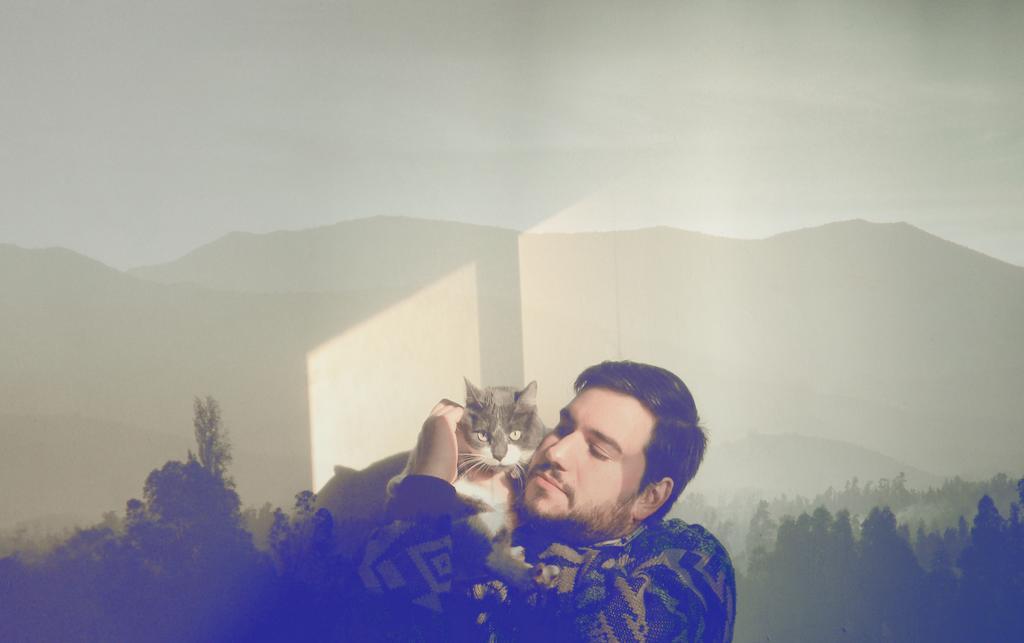Could you give a brief overview of what you see in this image? There is a man in the image holding a cat on his hands. In background we can see some trees and mountains and sky is on top. 